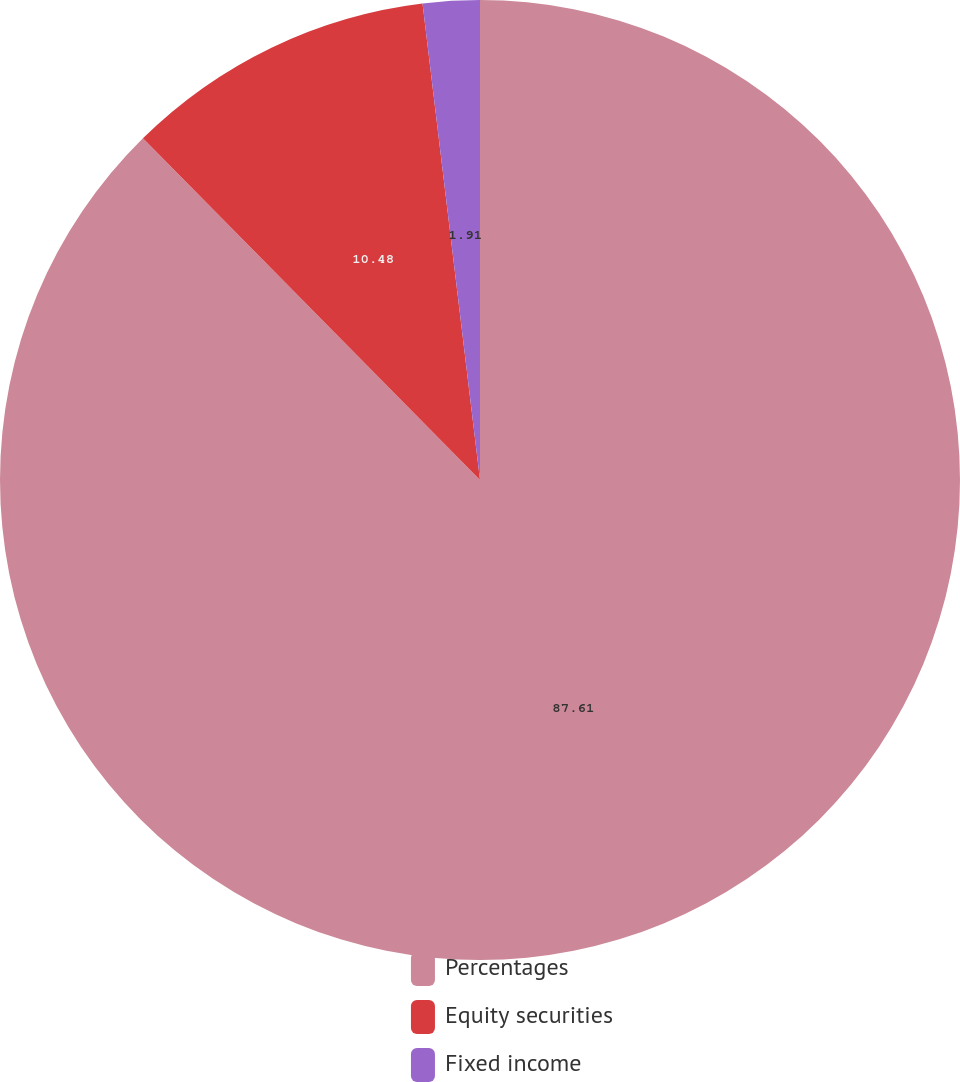<chart> <loc_0><loc_0><loc_500><loc_500><pie_chart><fcel>Percentages<fcel>Equity securities<fcel>Fixed income<nl><fcel>87.6%<fcel>10.48%<fcel>1.91%<nl></chart> 